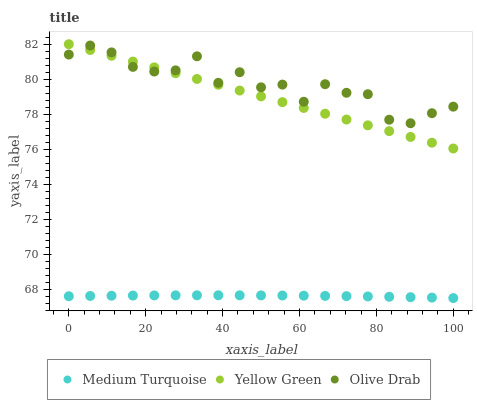Does Medium Turquoise have the minimum area under the curve?
Answer yes or no. Yes. Does Olive Drab have the maximum area under the curve?
Answer yes or no. Yes. Does Yellow Green have the minimum area under the curve?
Answer yes or no. No. Does Yellow Green have the maximum area under the curve?
Answer yes or no. No. Is Yellow Green the smoothest?
Answer yes or no. Yes. Is Olive Drab the roughest?
Answer yes or no. Yes. Is Medium Turquoise the smoothest?
Answer yes or no. No. Is Medium Turquoise the roughest?
Answer yes or no. No. Does Medium Turquoise have the lowest value?
Answer yes or no. Yes. Does Yellow Green have the lowest value?
Answer yes or no. No. Does Yellow Green have the highest value?
Answer yes or no. Yes. Does Medium Turquoise have the highest value?
Answer yes or no. No. Is Medium Turquoise less than Yellow Green?
Answer yes or no. Yes. Is Yellow Green greater than Medium Turquoise?
Answer yes or no. Yes. Does Olive Drab intersect Yellow Green?
Answer yes or no. Yes. Is Olive Drab less than Yellow Green?
Answer yes or no. No. Is Olive Drab greater than Yellow Green?
Answer yes or no. No. Does Medium Turquoise intersect Yellow Green?
Answer yes or no. No. 